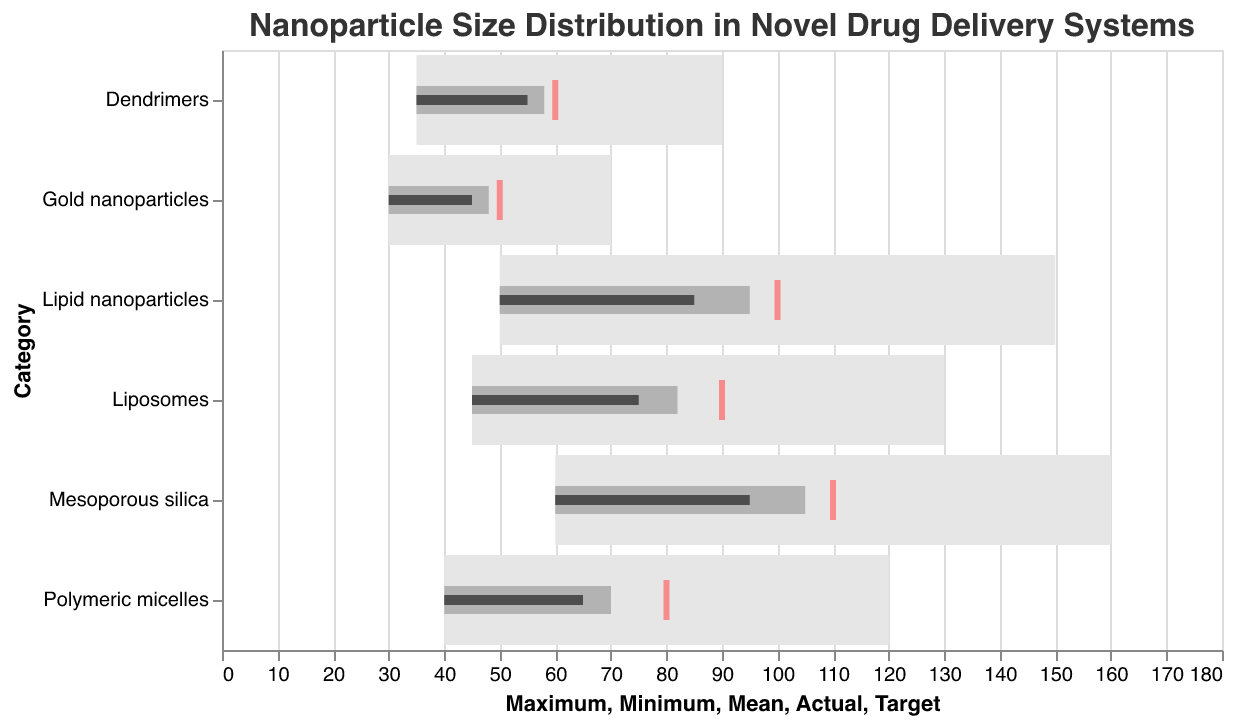What is the title of the chart? The title of the chart is displayed prominently at the top of the figure.
Answer: Nanoparticle Size Distribution in Novel Drug Delivery Systems What is the actual size of Gold nanoparticles? Refer to the 'Actual' value for Gold nanoparticles in the data plot.
Answer: 45 Which nanoparticle category has the highest minimum size? Look for the highest 'Minimum' value across all categories in the figure.
Answer: Mesoporous silica How much larger is the target size compared to the actual size for Liposomal nanoparticles? Subtract the 'Actual' value from the 'Target' value for Liposomal nanoparticles.
Answer: 15 What is the mean size for Dendrimers? Locate the 'Mean' size value for Dendrimers in the data plot.
Answer: 58 Which nanoparticle category falls short of its target size by the largest margin? Calculate the difference between 'Target' and 'Actual' sizes for each category and identify the largest one.
Answer: Mesoporous silica What is the range of sizes (maximum - minimum) for Polymeric micelles? Subtract the 'Minimum' value from the 'Maximum' value for Polymeric micelles.
Answer: 80 Is the actual size of Mesoporous silica greater than the mean size of Liposomes? Compare the 'Actual' size value of Mesoporous silica to the 'Mean' size value of Liposomes.
Answer: Yes What overall trend is indicated in the comparison of actual sizes versus target sizes for all categories? Observe the differences between 'Actual' and 'Target' sizes across all categories and summarize the trend.
Answer: Most actual sizes are below the target sizes How does the width of the bar for the minimum to maximum range appear visually in comparison to the actual size marker for Gold nanoparticles? Compare the width of the light-colored bar (representing minimum to maximum) to the position of the dark bar (representing the actual size) for Gold nanoparticles.
Answer: The light-colored bar is wider and exceeds the position of the dark bar 